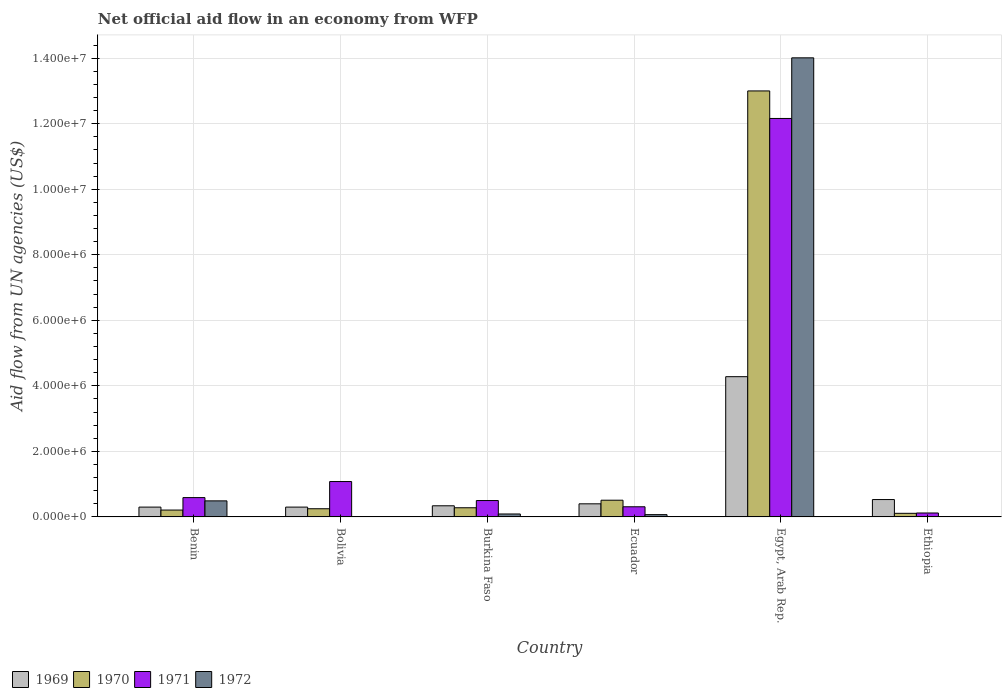Across all countries, what is the maximum net official aid flow in 1969?
Ensure brevity in your answer.  4.28e+06. Across all countries, what is the minimum net official aid flow in 1972?
Keep it short and to the point. 0. In which country was the net official aid flow in 1969 maximum?
Provide a short and direct response. Egypt, Arab Rep. What is the total net official aid flow in 1969 in the graph?
Your response must be concise. 6.15e+06. What is the difference between the net official aid flow in 1969 in Bolivia and that in Ecuador?
Provide a succinct answer. -1.00e+05. What is the average net official aid flow in 1969 per country?
Give a very brief answer. 1.02e+06. What is the difference between the net official aid flow of/in 1969 and net official aid flow of/in 1970 in Benin?
Your answer should be compact. 9.00e+04. What is the ratio of the net official aid flow in 1969 in Ecuador to that in Ethiopia?
Offer a terse response. 0.75. What is the difference between the highest and the second highest net official aid flow in 1972?
Provide a succinct answer. 1.35e+07. What is the difference between the highest and the lowest net official aid flow in 1972?
Your answer should be compact. 1.40e+07. In how many countries, is the net official aid flow in 1972 greater than the average net official aid flow in 1972 taken over all countries?
Ensure brevity in your answer.  1. Is it the case that in every country, the sum of the net official aid flow in 1971 and net official aid flow in 1972 is greater than the net official aid flow in 1969?
Make the answer very short. No. Are all the bars in the graph horizontal?
Offer a terse response. No. Does the graph contain any zero values?
Give a very brief answer. Yes. Does the graph contain grids?
Offer a terse response. Yes. How many legend labels are there?
Provide a short and direct response. 4. What is the title of the graph?
Offer a terse response. Net official aid flow in an economy from WFP. What is the label or title of the X-axis?
Your answer should be very brief. Country. What is the label or title of the Y-axis?
Ensure brevity in your answer.  Aid flow from UN agencies (US$). What is the Aid flow from UN agencies (US$) in 1969 in Benin?
Offer a terse response. 3.00e+05. What is the Aid flow from UN agencies (US$) in 1970 in Benin?
Give a very brief answer. 2.10e+05. What is the Aid flow from UN agencies (US$) of 1971 in Benin?
Offer a very short reply. 5.90e+05. What is the Aid flow from UN agencies (US$) in 1972 in Benin?
Provide a short and direct response. 4.90e+05. What is the Aid flow from UN agencies (US$) in 1969 in Bolivia?
Provide a succinct answer. 3.00e+05. What is the Aid flow from UN agencies (US$) in 1970 in Bolivia?
Provide a succinct answer. 2.50e+05. What is the Aid flow from UN agencies (US$) of 1971 in Bolivia?
Offer a terse response. 1.08e+06. What is the Aid flow from UN agencies (US$) of 1970 in Burkina Faso?
Ensure brevity in your answer.  2.80e+05. What is the Aid flow from UN agencies (US$) of 1969 in Ecuador?
Offer a terse response. 4.00e+05. What is the Aid flow from UN agencies (US$) in 1970 in Ecuador?
Offer a terse response. 5.10e+05. What is the Aid flow from UN agencies (US$) of 1971 in Ecuador?
Provide a short and direct response. 3.10e+05. What is the Aid flow from UN agencies (US$) in 1969 in Egypt, Arab Rep.?
Make the answer very short. 4.28e+06. What is the Aid flow from UN agencies (US$) of 1970 in Egypt, Arab Rep.?
Give a very brief answer. 1.30e+07. What is the Aid flow from UN agencies (US$) of 1971 in Egypt, Arab Rep.?
Give a very brief answer. 1.22e+07. What is the Aid flow from UN agencies (US$) in 1972 in Egypt, Arab Rep.?
Offer a very short reply. 1.40e+07. What is the Aid flow from UN agencies (US$) of 1969 in Ethiopia?
Provide a short and direct response. 5.30e+05. Across all countries, what is the maximum Aid flow from UN agencies (US$) in 1969?
Provide a succinct answer. 4.28e+06. Across all countries, what is the maximum Aid flow from UN agencies (US$) of 1970?
Your response must be concise. 1.30e+07. Across all countries, what is the maximum Aid flow from UN agencies (US$) in 1971?
Keep it short and to the point. 1.22e+07. Across all countries, what is the maximum Aid flow from UN agencies (US$) in 1972?
Your response must be concise. 1.40e+07. Across all countries, what is the minimum Aid flow from UN agencies (US$) of 1970?
Make the answer very short. 1.10e+05. Across all countries, what is the minimum Aid flow from UN agencies (US$) of 1972?
Provide a succinct answer. 0. What is the total Aid flow from UN agencies (US$) in 1969 in the graph?
Ensure brevity in your answer.  6.15e+06. What is the total Aid flow from UN agencies (US$) in 1970 in the graph?
Provide a short and direct response. 1.44e+07. What is the total Aid flow from UN agencies (US$) in 1971 in the graph?
Make the answer very short. 1.48e+07. What is the total Aid flow from UN agencies (US$) of 1972 in the graph?
Make the answer very short. 1.47e+07. What is the difference between the Aid flow from UN agencies (US$) in 1970 in Benin and that in Bolivia?
Make the answer very short. -4.00e+04. What is the difference between the Aid flow from UN agencies (US$) of 1971 in Benin and that in Bolivia?
Offer a very short reply. -4.90e+05. What is the difference between the Aid flow from UN agencies (US$) of 1969 in Benin and that in Ecuador?
Keep it short and to the point. -1.00e+05. What is the difference between the Aid flow from UN agencies (US$) of 1970 in Benin and that in Ecuador?
Provide a succinct answer. -3.00e+05. What is the difference between the Aid flow from UN agencies (US$) in 1971 in Benin and that in Ecuador?
Your answer should be very brief. 2.80e+05. What is the difference between the Aid flow from UN agencies (US$) of 1972 in Benin and that in Ecuador?
Your answer should be compact. 4.20e+05. What is the difference between the Aid flow from UN agencies (US$) of 1969 in Benin and that in Egypt, Arab Rep.?
Your answer should be very brief. -3.98e+06. What is the difference between the Aid flow from UN agencies (US$) in 1970 in Benin and that in Egypt, Arab Rep.?
Offer a very short reply. -1.28e+07. What is the difference between the Aid flow from UN agencies (US$) in 1971 in Benin and that in Egypt, Arab Rep.?
Provide a succinct answer. -1.16e+07. What is the difference between the Aid flow from UN agencies (US$) of 1972 in Benin and that in Egypt, Arab Rep.?
Give a very brief answer. -1.35e+07. What is the difference between the Aid flow from UN agencies (US$) of 1969 in Benin and that in Ethiopia?
Keep it short and to the point. -2.30e+05. What is the difference between the Aid flow from UN agencies (US$) of 1970 in Benin and that in Ethiopia?
Provide a succinct answer. 1.00e+05. What is the difference between the Aid flow from UN agencies (US$) in 1970 in Bolivia and that in Burkina Faso?
Give a very brief answer. -3.00e+04. What is the difference between the Aid flow from UN agencies (US$) of 1971 in Bolivia and that in Burkina Faso?
Your response must be concise. 5.80e+05. What is the difference between the Aid flow from UN agencies (US$) of 1969 in Bolivia and that in Ecuador?
Make the answer very short. -1.00e+05. What is the difference between the Aid flow from UN agencies (US$) in 1970 in Bolivia and that in Ecuador?
Give a very brief answer. -2.60e+05. What is the difference between the Aid flow from UN agencies (US$) in 1971 in Bolivia and that in Ecuador?
Give a very brief answer. 7.70e+05. What is the difference between the Aid flow from UN agencies (US$) of 1969 in Bolivia and that in Egypt, Arab Rep.?
Offer a terse response. -3.98e+06. What is the difference between the Aid flow from UN agencies (US$) in 1970 in Bolivia and that in Egypt, Arab Rep.?
Provide a short and direct response. -1.28e+07. What is the difference between the Aid flow from UN agencies (US$) in 1971 in Bolivia and that in Egypt, Arab Rep.?
Offer a terse response. -1.11e+07. What is the difference between the Aid flow from UN agencies (US$) of 1971 in Bolivia and that in Ethiopia?
Ensure brevity in your answer.  9.60e+05. What is the difference between the Aid flow from UN agencies (US$) of 1970 in Burkina Faso and that in Ecuador?
Provide a short and direct response. -2.30e+05. What is the difference between the Aid flow from UN agencies (US$) in 1971 in Burkina Faso and that in Ecuador?
Your answer should be compact. 1.90e+05. What is the difference between the Aid flow from UN agencies (US$) in 1969 in Burkina Faso and that in Egypt, Arab Rep.?
Give a very brief answer. -3.94e+06. What is the difference between the Aid flow from UN agencies (US$) in 1970 in Burkina Faso and that in Egypt, Arab Rep.?
Provide a succinct answer. -1.27e+07. What is the difference between the Aid flow from UN agencies (US$) in 1971 in Burkina Faso and that in Egypt, Arab Rep.?
Ensure brevity in your answer.  -1.17e+07. What is the difference between the Aid flow from UN agencies (US$) of 1972 in Burkina Faso and that in Egypt, Arab Rep.?
Your answer should be very brief. -1.39e+07. What is the difference between the Aid flow from UN agencies (US$) in 1969 in Burkina Faso and that in Ethiopia?
Your answer should be very brief. -1.90e+05. What is the difference between the Aid flow from UN agencies (US$) in 1971 in Burkina Faso and that in Ethiopia?
Ensure brevity in your answer.  3.80e+05. What is the difference between the Aid flow from UN agencies (US$) in 1969 in Ecuador and that in Egypt, Arab Rep.?
Ensure brevity in your answer.  -3.88e+06. What is the difference between the Aid flow from UN agencies (US$) in 1970 in Ecuador and that in Egypt, Arab Rep.?
Your answer should be compact. -1.25e+07. What is the difference between the Aid flow from UN agencies (US$) of 1971 in Ecuador and that in Egypt, Arab Rep.?
Give a very brief answer. -1.18e+07. What is the difference between the Aid flow from UN agencies (US$) of 1972 in Ecuador and that in Egypt, Arab Rep.?
Offer a very short reply. -1.39e+07. What is the difference between the Aid flow from UN agencies (US$) in 1969 in Ecuador and that in Ethiopia?
Your answer should be compact. -1.30e+05. What is the difference between the Aid flow from UN agencies (US$) of 1969 in Egypt, Arab Rep. and that in Ethiopia?
Make the answer very short. 3.75e+06. What is the difference between the Aid flow from UN agencies (US$) in 1970 in Egypt, Arab Rep. and that in Ethiopia?
Provide a short and direct response. 1.29e+07. What is the difference between the Aid flow from UN agencies (US$) of 1971 in Egypt, Arab Rep. and that in Ethiopia?
Your answer should be very brief. 1.20e+07. What is the difference between the Aid flow from UN agencies (US$) of 1969 in Benin and the Aid flow from UN agencies (US$) of 1970 in Bolivia?
Provide a short and direct response. 5.00e+04. What is the difference between the Aid flow from UN agencies (US$) of 1969 in Benin and the Aid flow from UN agencies (US$) of 1971 in Bolivia?
Make the answer very short. -7.80e+05. What is the difference between the Aid flow from UN agencies (US$) in 1970 in Benin and the Aid flow from UN agencies (US$) in 1971 in Bolivia?
Offer a very short reply. -8.70e+05. What is the difference between the Aid flow from UN agencies (US$) of 1969 in Benin and the Aid flow from UN agencies (US$) of 1971 in Burkina Faso?
Provide a succinct answer. -2.00e+05. What is the difference between the Aid flow from UN agencies (US$) in 1969 in Benin and the Aid flow from UN agencies (US$) in 1972 in Burkina Faso?
Provide a succinct answer. 2.10e+05. What is the difference between the Aid flow from UN agencies (US$) in 1970 in Benin and the Aid flow from UN agencies (US$) in 1971 in Burkina Faso?
Give a very brief answer. -2.90e+05. What is the difference between the Aid flow from UN agencies (US$) in 1971 in Benin and the Aid flow from UN agencies (US$) in 1972 in Burkina Faso?
Your answer should be compact. 5.00e+05. What is the difference between the Aid flow from UN agencies (US$) in 1969 in Benin and the Aid flow from UN agencies (US$) in 1970 in Ecuador?
Provide a succinct answer. -2.10e+05. What is the difference between the Aid flow from UN agencies (US$) of 1970 in Benin and the Aid flow from UN agencies (US$) of 1972 in Ecuador?
Provide a short and direct response. 1.40e+05. What is the difference between the Aid flow from UN agencies (US$) of 1971 in Benin and the Aid flow from UN agencies (US$) of 1972 in Ecuador?
Provide a succinct answer. 5.20e+05. What is the difference between the Aid flow from UN agencies (US$) of 1969 in Benin and the Aid flow from UN agencies (US$) of 1970 in Egypt, Arab Rep.?
Offer a terse response. -1.27e+07. What is the difference between the Aid flow from UN agencies (US$) of 1969 in Benin and the Aid flow from UN agencies (US$) of 1971 in Egypt, Arab Rep.?
Your answer should be compact. -1.19e+07. What is the difference between the Aid flow from UN agencies (US$) in 1969 in Benin and the Aid flow from UN agencies (US$) in 1972 in Egypt, Arab Rep.?
Provide a short and direct response. -1.37e+07. What is the difference between the Aid flow from UN agencies (US$) in 1970 in Benin and the Aid flow from UN agencies (US$) in 1971 in Egypt, Arab Rep.?
Your answer should be very brief. -1.20e+07. What is the difference between the Aid flow from UN agencies (US$) of 1970 in Benin and the Aid flow from UN agencies (US$) of 1972 in Egypt, Arab Rep.?
Ensure brevity in your answer.  -1.38e+07. What is the difference between the Aid flow from UN agencies (US$) of 1971 in Benin and the Aid flow from UN agencies (US$) of 1972 in Egypt, Arab Rep.?
Make the answer very short. -1.34e+07. What is the difference between the Aid flow from UN agencies (US$) in 1969 in Benin and the Aid flow from UN agencies (US$) in 1970 in Ethiopia?
Give a very brief answer. 1.90e+05. What is the difference between the Aid flow from UN agencies (US$) of 1969 in Bolivia and the Aid flow from UN agencies (US$) of 1970 in Burkina Faso?
Offer a terse response. 2.00e+04. What is the difference between the Aid flow from UN agencies (US$) of 1969 in Bolivia and the Aid flow from UN agencies (US$) of 1971 in Burkina Faso?
Your response must be concise. -2.00e+05. What is the difference between the Aid flow from UN agencies (US$) of 1971 in Bolivia and the Aid flow from UN agencies (US$) of 1972 in Burkina Faso?
Provide a short and direct response. 9.90e+05. What is the difference between the Aid flow from UN agencies (US$) of 1969 in Bolivia and the Aid flow from UN agencies (US$) of 1970 in Ecuador?
Offer a very short reply. -2.10e+05. What is the difference between the Aid flow from UN agencies (US$) in 1969 in Bolivia and the Aid flow from UN agencies (US$) in 1971 in Ecuador?
Provide a succinct answer. -10000. What is the difference between the Aid flow from UN agencies (US$) of 1970 in Bolivia and the Aid flow from UN agencies (US$) of 1971 in Ecuador?
Ensure brevity in your answer.  -6.00e+04. What is the difference between the Aid flow from UN agencies (US$) of 1971 in Bolivia and the Aid flow from UN agencies (US$) of 1972 in Ecuador?
Your answer should be very brief. 1.01e+06. What is the difference between the Aid flow from UN agencies (US$) in 1969 in Bolivia and the Aid flow from UN agencies (US$) in 1970 in Egypt, Arab Rep.?
Your answer should be compact. -1.27e+07. What is the difference between the Aid flow from UN agencies (US$) in 1969 in Bolivia and the Aid flow from UN agencies (US$) in 1971 in Egypt, Arab Rep.?
Your answer should be compact. -1.19e+07. What is the difference between the Aid flow from UN agencies (US$) of 1969 in Bolivia and the Aid flow from UN agencies (US$) of 1972 in Egypt, Arab Rep.?
Your answer should be compact. -1.37e+07. What is the difference between the Aid flow from UN agencies (US$) in 1970 in Bolivia and the Aid flow from UN agencies (US$) in 1971 in Egypt, Arab Rep.?
Provide a succinct answer. -1.19e+07. What is the difference between the Aid flow from UN agencies (US$) of 1970 in Bolivia and the Aid flow from UN agencies (US$) of 1972 in Egypt, Arab Rep.?
Provide a short and direct response. -1.38e+07. What is the difference between the Aid flow from UN agencies (US$) of 1971 in Bolivia and the Aid flow from UN agencies (US$) of 1972 in Egypt, Arab Rep.?
Make the answer very short. -1.29e+07. What is the difference between the Aid flow from UN agencies (US$) in 1969 in Bolivia and the Aid flow from UN agencies (US$) in 1970 in Ethiopia?
Offer a terse response. 1.90e+05. What is the difference between the Aid flow from UN agencies (US$) of 1969 in Bolivia and the Aid flow from UN agencies (US$) of 1971 in Ethiopia?
Your response must be concise. 1.80e+05. What is the difference between the Aid flow from UN agencies (US$) of 1970 in Bolivia and the Aid flow from UN agencies (US$) of 1971 in Ethiopia?
Offer a terse response. 1.30e+05. What is the difference between the Aid flow from UN agencies (US$) in 1970 in Burkina Faso and the Aid flow from UN agencies (US$) in 1971 in Ecuador?
Your answer should be very brief. -3.00e+04. What is the difference between the Aid flow from UN agencies (US$) of 1971 in Burkina Faso and the Aid flow from UN agencies (US$) of 1972 in Ecuador?
Make the answer very short. 4.30e+05. What is the difference between the Aid flow from UN agencies (US$) of 1969 in Burkina Faso and the Aid flow from UN agencies (US$) of 1970 in Egypt, Arab Rep.?
Make the answer very short. -1.27e+07. What is the difference between the Aid flow from UN agencies (US$) in 1969 in Burkina Faso and the Aid flow from UN agencies (US$) in 1971 in Egypt, Arab Rep.?
Provide a succinct answer. -1.18e+07. What is the difference between the Aid flow from UN agencies (US$) of 1969 in Burkina Faso and the Aid flow from UN agencies (US$) of 1972 in Egypt, Arab Rep.?
Give a very brief answer. -1.37e+07. What is the difference between the Aid flow from UN agencies (US$) of 1970 in Burkina Faso and the Aid flow from UN agencies (US$) of 1971 in Egypt, Arab Rep.?
Make the answer very short. -1.19e+07. What is the difference between the Aid flow from UN agencies (US$) of 1970 in Burkina Faso and the Aid flow from UN agencies (US$) of 1972 in Egypt, Arab Rep.?
Your answer should be compact. -1.37e+07. What is the difference between the Aid flow from UN agencies (US$) in 1971 in Burkina Faso and the Aid flow from UN agencies (US$) in 1972 in Egypt, Arab Rep.?
Your answer should be very brief. -1.35e+07. What is the difference between the Aid flow from UN agencies (US$) of 1969 in Burkina Faso and the Aid flow from UN agencies (US$) of 1970 in Ethiopia?
Your answer should be very brief. 2.30e+05. What is the difference between the Aid flow from UN agencies (US$) of 1969 in Burkina Faso and the Aid flow from UN agencies (US$) of 1971 in Ethiopia?
Ensure brevity in your answer.  2.20e+05. What is the difference between the Aid flow from UN agencies (US$) in 1970 in Burkina Faso and the Aid flow from UN agencies (US$) in 1971 in Ethiopia?
Provide a succinct answer. 1.60e+05. What is the difference between the Aid flow from UN agencies (US$) of 1969 in Ecuador and the Aid flow from UN agencies (US$) of 1970 in Egypt, Arab Rep.?
Offer a terse response. -1.26e+07. What is the difference between the Aid flow from UN agencies (US$) in 1969 in Ecuador and the Aid flow from UN agencies (US$) in 1971 in Egypt, Arab Rep.?
Ensure brevity in your answer.  -1.18e+07. What is the difference between the Aid flow from UN agencies (US$) of 1969 in Ecuador and the Aid flow from UN agencies (US$) of 1972 in Egypt, Arab Rep.?
Provide a short and direct response. -1.36e+07. What is the difference between the Aid flow from UN agencies (US$) of 1970 in Ecuador and the Aid flow from UN agencies (US$) of 1971 in Egypt, Arab Rep.?
Provide a short and direct response. -1.16e+07. What is the difference between the Aid flow from UN agencies (US$) of 1970 in Ecuador and the Aid flow from UN agencies (US$) of 1972 in Egypt, Arab Rep.?
Your response must be concise. -1.35e+07. What is the difference between the Aid flow from UN agencies (US$) in 1971 in Ecuador and the Aid flow from UN agencies (US$) in 1972 in Egypt, Arab Rep.?
Your answer should be very brief. -1.37e+07. What is the difference between the Aid flow from UN agencies (US$) of 1969 in Egypt, Arab Rep. and the Aid flow from UN agencies (US$) of 1970 in Ethiopia?
Make the answer very short. 4.17e+06. What is the difference between the Aid flow from UN agencies (US$) in 1969 in Egypt, Arab Rep. and the Aid flow from UN agencies (US$) in 1971 in Ethiopia?
Provide a succinct answer. 4.16e+06. What is the difference between the Aid flow from UN agencies (US$) in 1970 in Egypt, Arab Rep. and the Aid flow from UN agencies (US$) in 1971 in Ethiopia?
Your response must be concise. 1.29e+07. What is the average Aid flow from UN agencies (US$) of 1969 per country?
Offer a very short reply. 1.02e+06. What is the average Aid flow from UN agencies (US$) of 1970 per country?
Make the answer very short. 2.39e+06. What is the average Aid flow from UN agencies (US$) in 1971 per country?
Give a very brief answer. 2.46e+06. What is the average Aid flow from UN agencies (US$) of 1972 per country?
Provide a succinct answer. 2.44e+06. What is the difference between the Aid flow from UN agencies (US$) of 1969 and Aid flow from UN agencies (US$) of 1970 in Benin?
Provide a short and direct response. 9.00e+04. What is the difference between the Aid flow from UN agencies (US$) in 1969 and Aid flow from UN agencies (US$) in 1971 in Benin?
Your response must be concise. -2.90e+05. What is the difference between the Aid flow from UN agencies (US$) of 1970 and Aid flow from UN agencies (US$) of 1971 in Benin?
Make the answer very short. -3.80e+05. What is the difference between the Aid flow from UN agencies (US$) in 1970 and Aid flow from UN agencies (US$) in 1972 in Benin?
Provide a short and direct response. -2.80e+05. What is the difference between the Aid flow from UN agencies (US$) of 1971 and Aid flow from UN agencies (US$) of 1972 in Benin?
Give a very brief answer. 1.00e+05. What is the difference between the Aid flow from UN agencies (US$) of 1969 and Aid flow from UN agencies (US$) of 1971 in Bolivia?
Provide a succinct answer. -7.80e+05. What is the difference between the Aid flow from UN agencies (US$) in 1970 and Aid flow from UN agencies (US$) in 1971 in Bolivia?
Provide a succinct answer. -8.30e+05. What is the difference between the Aid flow from UN agencies (US$) in 1970 and Aid flow from UN agencies (US$) in 1971 in Burkina Faso?
Offer a very short reply. -2.20e+05. What is the difference between the Aid flow from UN agencies (US$) of 1969 and Aid flow from UN agencies (US$) of 1972 in Ecuador?
Your answer should be compact. 3.30e+05. What is the difference between the Aid flow from UN agencies (US$) of 1970 and Aid flow from UN agencies (US$) of 1971 in Ecuador?
Your response must be concise. 2.00e+05. What is the difference between the Aid flow from UN agencies (US$) of 1970 and Aid flow from UN agencies (US$) of 1972 in Ecuador?
Make the answer very short. 4.40e+05. What is the difference between the Aid flow from UN agencies (US$) in 1969 and Aid flow from UN agencies (US$) in 1970 in Egypt, Arab Rep.?
Ensure brevity in your answer.  -8.72e+06. What is the difference between the Aid flow from UN agencies (US$) of 1969 and Aid flow from UN agencies (US$) of 1971 in Egypt, Arab Rep.?
Offer a terse response. -7.88e+06. What is the difference between the Aid flow from UN agencies (US$) in 1969 and Aid flow from UN agencies (US$) in 1972 in Egypt, Arab Rep.?
Ensure brevity in your answer.  -9.73e+06. What is the difference between the Aid flow from UN agencies (US$) of 1970 and Aid flow from UN agencies (US$) of 1971 in Egypt, Arab Rep.?
Keep it short and to the point. 8.40e+05. What is the difference between the Aid flow from UN agencies (US$) in 1970 and Aid flow from UN agencies (US$) in 1972 in Egypt, Arab Rep.?
Your response must be concise. -1.01e+06. What is the difference between the Aid flow from UN agencies (US$) in 1971 and Aid flow from UN agencies (US$) in 1972 in Egypt, Arab Rep.?
Offer a very short reply. -1.85e+06. What is the difference between the Aid flow from UN agencies (US$) of 1969 and Aid flow from UN agencies (US$) of 1970 in Ethiopia?
Keep it short and to the point. 4.20e+05. What is the difference between the Aid flow from UN agencies (US$) in 1970 and Aid flow from UN agencies (US$) in 1971 in Ethiopia?
Provide a short and direct response. -10000. What is the ratio of the Aid flow from UN agencies (US$) in 1969 in Benin to that in Bolivia?
Your answer should be very brief. 1. What is the ratio of the Aid flow from UN agencies (US$) of 1970 in Benin to that in Bolivia?
Make the answer very short. 0.84. What is the ratio of the Aid flow from UN agencies (US$) in 1971 in Benin to that in Bolivia?
Ensure brevity in your answer.  0.55. What is the ratio of the Aid flow from UN agencies (US$) in 1969 in Benin to that in Burkina Faso?
Offer a terse response. 0.88. What is the ratio of the Aid flow from UN agencies (US$) of 1970 in Benin to that in Burkina Faso?
Offer a terse response. 0.75. What is the ratio of the Aid flow from UN agencies (US$) of 1971 in Benin to that in Burkina Faso?
Your answer should be compact. 1.18. What is the ratio of the Aid flow from UN agencies (US$) of 1972 in Benin to that in Burkina Faso?
Make the answer very short. 5.44. What is the ratio of the Aid flow from UN agencies (US$) of 1969 in Benin to that in Ecuador?
Your answer should be compact. 0.75. What is the ratio of the Aid flow from UN agencies (US$) in 1970 in Benin to that in Ecuador?
Provide a short and direct response. 0.41. What is the ratio of the Aid flow from UN agencies (US$) of 1971 in Benin to that in Ecuador?
Give a very brief answer. 1.9. What is the ratio of the Aid flow from UN agencies (US$) of 1972 in Benin to that in Ecuador?
Offer a terse response. 7. What is the ratio of the Aid flow from UN agencies (US$) in 1969 in Benin to that in Egypt, Arab Rep.?
Give a very brief answer. 0.07. What is the ratio of the Aid flow from UN agencies (US$) of 1970 in Benin to that in Egypt, Arab Rep.?
Provide a short and direct response. 0.02. What is the ratio of the Aid flow from UN agencies (US$) of 1971 in Benin to that in Egypt, Arab Rep.?
Offer a terse response. 0.05. What is the ratio of the Aid flow from UN agencies (US$) of 1972 in Benin to that in Egypt, Arab Rep.?
Keep it short and to the point. 0.04. What is the ratio of the Aid flow from UN agencies (US$) in 1969 in Benin to that in Ethiopia?
Your response must be concise. 0.57. What is the ratio of the Aid flow from UN agencies (US$) in 1970 in Benin to that in Ethiopia?
Make the answer very short. 1.91. What is the ratio of the Aid flow from UN agencies (US$) of 1971 in Benin to that in Ethiopia?
Provide a short and direct response. 4.92. What is the ratio of the Aid flow from UN agencies (US$) in 1969 in Bolivia to that in Burkina Faso?
Ensure brevity in your answer.  0.88. What is the ratio of the Aid flow from UN agencies (US$) of 1970 in Bolivia to that in Burkina Faso?
Ensure brevity in your answer.  0.89. What is the ratio of the Aid flow from UN agencies (US$) of 1971 in Bolivia to that in Burkina Faso?
Your answer should be compact. 2.16. What is the ratio of the Aid flow from UN agencies (US$) in 1970 in Bolivia to that in Ecuador?
Make the answer very short. 0.49. What is the ratio of the Aid flow from UN agencies (US$) of 1971 in Bolivia to that in Ecuador?
Provide a short and direct response. 3.48. What is the ratio of the Aid flow from UN agencies (US$) of 1969 in Bolivia to that in Egypt, Arab Rep.?
Keep it short and to the point. 0.07. What is the ratio of the Aid flow from UN agencies (US$) of 1970 in Bolivia to that in Egypt, Arab Rep.?
Keep it short and to the point. 0.02. What is the ratio of the Aid flow from UN agencies (US$) of 1971 in Bolivia to that in Egypt, Arab Rep.?
Your answer should be compact. 0.09. What is the ratio of the Aid flow from UN agencies (US$) in 1969 in Bolivia to that in Ethiopia?
Provide a short and direct response. 0.57. What is the ratio of the Aid flow from UN agencies (US$) in 1970 in Bolivia to that in Ethiopia?
Your answer should be compact. 2.27. What is the ratio of the Aid flow from UN agencies (US$) in 1971 in Bolivia to that in Ethiopia?
Provide a succinct answer. 9. What is the ratio of the Aid flow from UN agencies (US$) in 1970 in Burkina Faso to that in Ecuador?
Your answer should be compact. 0.55. What is the ratio of the Aid flow from UN agencies (US$) of 1971 in Burkina Faso to that in Ecuador?
Make the answer very short. 1.61. What is the ratio of the Aid flow from UN agencies (US$) of 1969 in Burkina Faso to that in Egypt, Arab Rep.?
Make the answer very short. 0.08. What is the ratio of the Aid flow from UN agencies (US$) of 1970 in Burkina Faso to that in Egypt, Arab Rep.?
Offer a terse response. 0.02. What is the ratio of the Aid flow from UN agencies (US$) of 1971 in Burkina Faso to that in Egypt, Arab Rep.?
Your answer should be very brief. 0.04. What is the ratio of the Aid flow from UN agencies (US$) of 1972 in Burkina Faso to that in Egypt, Arab Rep.?
Provide a short and direct response. 0.01. What is the ratio of the Aid flow from UN agencies (US$) of 1969 in Burkina Faso to that in Ethiopia?
Keep it short and to the point. 0.64. What is the ratio of the Aid flow from UN agencies (US$) of 1970 in Burkina Faso to that in Ethiopia?
Provide a succinct answer. 2.55. What is the ratio of the Aid flow from UN agencies (US$) of 1971 in Burkina Faso to that in Ethiopia?
Offer a terse response. 4.17. What is the ratio of the Aid flow from UN agencies (US$) of 1969 in Ecuador to that in Egypt, Arab Rep.?
Your answer should be very brief. 0.09. What is the ratio of the Aid flow from UN agencies (US$) of 1970 in Ecuador to that in Egypt, Arab Rep.?
Ensure brevity in your answer.  0.04. What is the ratio of the Aid flow from UN agencies (US$) in 1971 in Ecuador to that in Egypt, Arab Rep.?
Your answer should be very brief. 0.03. What is the ratio of the Aid flow from UN agencies (US$) of 1972 in Ecuador to that in Egypt, Arab Rep.?
Give a very brief answer. 0.01. What is the ratio of the Aid flow from UN agencies (US$) in 1969 in Ecuador to that in Ethiopia?
Give a very brief answer. 0.75. What is the ratio of the Aid flow from UN agencies (US$) in 1970 in Ecuador to that in Ethiopia?
Make the answer very short. 4.64. What is the ratio of the Aid flow from UN agencies (US$) of 1971 in Ecuador to that in Ethiopia?
Give a very brief answer. 2.58. What is the ratio of the Aid flow from UN agencies (US$) of 1969 in Egypt, Arab Rep. to that in Ethiopia?
Provide a short and direct response. 8.08. What is the ratio of the Aid flow from UN agencies (US$) of 1970 in Egypt, Arab Rep. to that in Ethiopia?
Keep it short and to the point. 118.18. What is the ratio of the Aid flow from UN agencies (US$) of 1971 in Egypt, Arab Rep. to that in Ethiopia?
Give a very brief answer. 101.33. What is the difference between the highest and the second highest Aid flow from UN agencies (US$) in 1969?
Offer a very short reply. 3.75e+06. What is the difference between the highest and the second highest Aid flow from UN agencies (US$) in 1970?
Provide a short and direct response. 1.25e+07. What is the difference between the highest and the second highest Aid flow from UN agencies (US$) of 1971?
Give a very brief answer. 1.11e+07. What is the difference between the highest and the second highest Aid flow from UN agencies (US$) in 1972?
Your response must be concise. 1.35e+07. What is the difference between the highest and the lowest Aid flow from UN agencies (US$) of 1969?
Offer a terse response. 3.98e+06. What is the difference between the highest and the lowest Aid flow from UN agencies (US$) of 1970?
Offer a very short reply. 1.29e+07. What is the difference between the highest and the lowest Aid flow from UN agencies (US$) of 1971?
Offer a terse response. 1.20e+07. What is the difference between the highest and the lowest Aid flow from UN agencies (US$) of 1972?
Ensure brevity in your answer.  1.40e+07. 